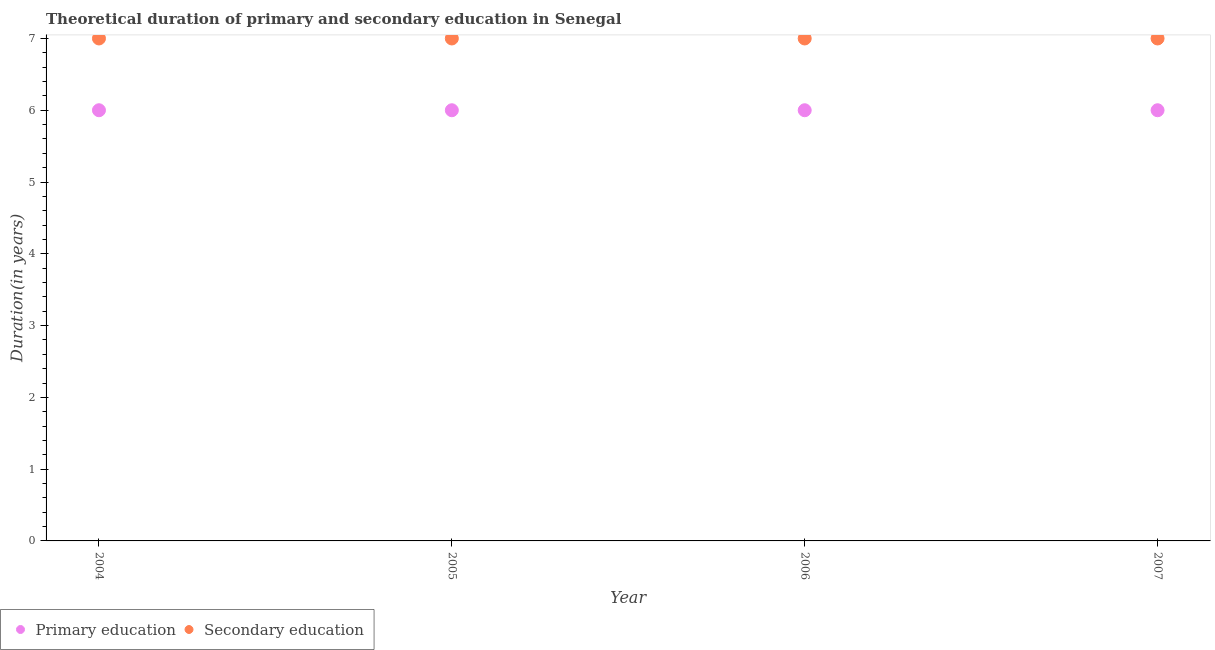How many different coloured dotlines are there?
Make the answer very short. 2. What is the duration of secondary education in 2005?
Ensure brevity in your answer.  7. Across all years, what is the maximum duration of secondary education?
Provide a short and direct response. 7. Across all years, what is the minimum duration of secondary education?
Provide a short and direct response. 7. In which year was the duration of primary education maximum?
Provide a short and direct response. 2004. What is the total duration of primary education in the graph?
Your response must be concise. 24. What is the difference between the duration of secondary education in 2006 and that in 2007?
Give a very brief answer. 0. What is the difference between the duration of secondary education in 2004 and the duration of primary education in 2005?
Offer a very short reply. 1. What is the average duration of secondary education per year?
Offer a very short reply. 7. In the year 2005, what is the difference between the duration of primary education and duration of secondary education?
Offer a very short reply. -1. In how many years, is the duration of secondary education greater than 1.6 years?
Your answer should be compact. 4. What is the ratio of the duration of primary education in 2004 to that in 2005?
Give a very brief answer. 1. Is the duration of secondary education in 2004 less than that in 2007?
Offer a very short reply. No. Is the difference between the duration of primary education in 2006 and 2007 greater than the difference between the duration of secondary education in 2006 and 2007?
Provide a succinct answer. No. What is the difference between the highest and the lowest duration of primary education?
Your answer should be compact. 0. In how many years, is the duration of secondary education greater than the average duration of secondary education taken over all years?
Your answer should be compact. 0. Does the duration of primary education monotonically increase over the years?
Provide a succinct answer. No. Is the duration of primary education strictly greater than the duration of secondary education over the years?
Ensure brevity in your answer.  No. Is the duration of secondary education strictly less than the duration of primary education over the years?
Provide a short and direct response. No. How many years are there in the graph?
Your response must be concise. 4. What is the difference between two consecutive major ticks on the Y-axis?
Your response must be concise. 1. Are the values on the major ticks of Y-axis written in scientific E-notation?
Provide a succinct answer. No. Does the graph contain any zero values?
Keep it short and to the point. No. Where does the legend appear in the graph?
Keep it short and to the point. Bottom left. What is the title of the graph?
Ensure brevity in your answer.  Theoretical duration of primary and secondary education in Senegal. What is the label or title of the Y-axis?
Your answer should be very brief. Duration(in years). What is the Duration(in years) of Primary education in 2004?
Offer a terse response. 6. What is the Duration(in years) of Secondary education in 2005?
Your response must be concise. 7. What is the Duration(in years) in Primary education in 2006?
Make the answer very short. 6. What is the Duration(in years) of Secondary education in 2007?
Your answer should be compact. 7. Across all years, what is the maximum Duration(in years) of Secondary education?
Offer a very short reply. 7. Across all years, what is the minimum Duration(in years) of Primary education?
Give a very brief answer. 6. What is the difference between the Duration(in years) in Primary education in 2004 and that in 2006?
Provide a succinct answer. 0. What is the difference between the Duration(in years) in Secondary education in 2004 and that in 2007?
Your answer should be very brief. 0. What is the difference between the Duration(in years) of Secondary education in 2005 and that in 2006?
Your response must be concise. 0. What is the difference between the Duration(in years) of Primary education in 2005 and that in 2007?
Your response must be concise. 0. What is the difference between the Duration(in years) of Secondary education in 2006 and that in 2007?
Offer a terse response. 0. What is the difference between the Duration(in years) of Primary education in 2004 and the Duration(in years) of Secondary education in 2005?
Make the answer very short. -1. What is the difference between the Duration(in years) in Primary education in 2004 and the Duration(in years) in Secondary education in 2006?
Your answer should be very brief. -1. What is the difference between the Duration(in years) of Primary education in 2005 and the Duration(in years) of Secondary education in 2007?
Your answer should be compact. -1. What is the difference between the Duration(in years) of Primary education in 2006 and the Duration(in years) of Secondary education in 2007?
Offer a very short reply. -1. What is the average Duration(in years) of Primary education per year?
Your answer should be compact. 6. What is the average Duration(in years) in Secondary education per year?
Give a very brief answer. 7. In the year 2004, what is the difference between the Duration(in years) of Primary education and Duration(in years) of Secondary education?
Make the answer very short. -1. In the year 2005, what is the difference between the Duration(in years) in Primary education and Duration(in years) in Secondary education?
Your answer should be very brief. -1. In the year 2006, what is the difference between the Duration(in years) of Primary education and Duration(in years) of Secondary education?
Your answer should be compact. -1. What is the ratio of the Duration(in years) of Secondary education in 2004 to that in 2005?
Your response must be concise. 1. What is the ratio of the Duration(in years) of Primary education in 2004 to that in 2007?
Ensure brevity in your answer.  1. What is the ratio of the Duration(in years) in Secondary education in 2004 to that in 2007?
Make the answer very short. 1. What is the ratio of the Duration(in years) in Primary education in 2005 to that in 2007?
Give a very brief answer. 1. What is the ratio of the Duration(in years) of Secondary education in 2005 to that in 2007?
Give a very brief answer. 1. What is the ratio of the Duration(in years) of Primary education in 2006 to that in 2007?
Offer a very short reply. 1. What is the difference between the highest and the lowest Duration(in years) of Primary education?
Provide a succinct answer. 0. What is the difference between the highest and the lowest Duration(in years) in Secondary education?
Give a very brief answer. 0. 